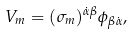Convert formula to latex. <formula><loc_0><loc_0><loc_500><loc_500>V _ { m } = ( \sigma _ { m } ) ^ { \dot { \alpha } \beta } \phi _ { \beta \dot { \alpha } } ,</formula> 